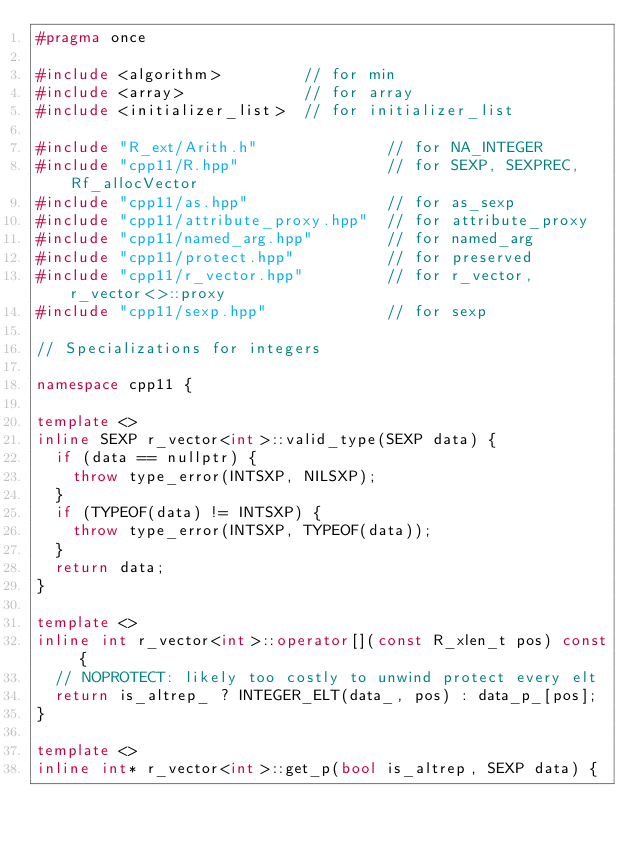Convert code to text. <code><loc_0><loc_0><loc_500><loc_500><_C++_>#pragma once

#include <algorithm>         // for min
#include <array>             // for array
#include <initializer_list>  // for initializer_list

#include "R_ext/Arith.h"              // for NA_INTEGER
#include "cpp11/R.hpp"                // for SEXP, SEXPREC, Rf_allocVector
#include "cpp11/as.hpp"               // for as_sexp
#include "cpp11/attribute_proxy.hpp"  // for attribute_proxy
#include "cpp11/named_arg.hpp"        // for named_arg
#include "cpp11/protect.hpp"          // for preserved
#include "cpp11/r_vector.hpp"         // for r_vector, r_vector<>::proxy
#include "cpp11/sexp.hpp"             // for sexp

// Specializations for integers

namespace cpp11 {

template <>
inline SEXP r_vector<int>::valid_type(SEXP data) {
  if (data == nullptr) {
    throw type_error(INTSXP, NILSXP);
  }
  if (TYPEOF(data) != INTSXP) {
    throw type_error(INTSXP, TYPEOF(data));
  }
  return data;
}

template <>
inline int r_vector<int>::operator[](const R_xlen_t pos) const {
  // NOPROTECT: likely too costly to unwind protect every elt
  return is_altrep_ ? INTEGER_ELT(data_, pos) : data_p_[pos];
}

template <>
inline int* r_vector<int>::get_p(bool is_altrep, SEXP data) {</code> 